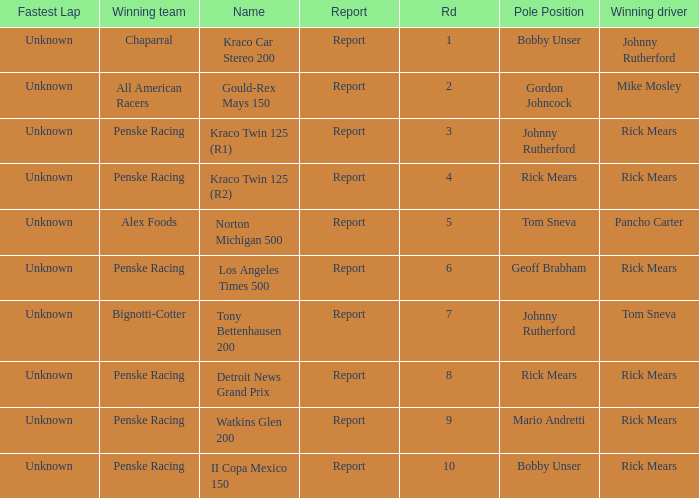How many fastest laps were there for a rd that equals 10? 1.0. 